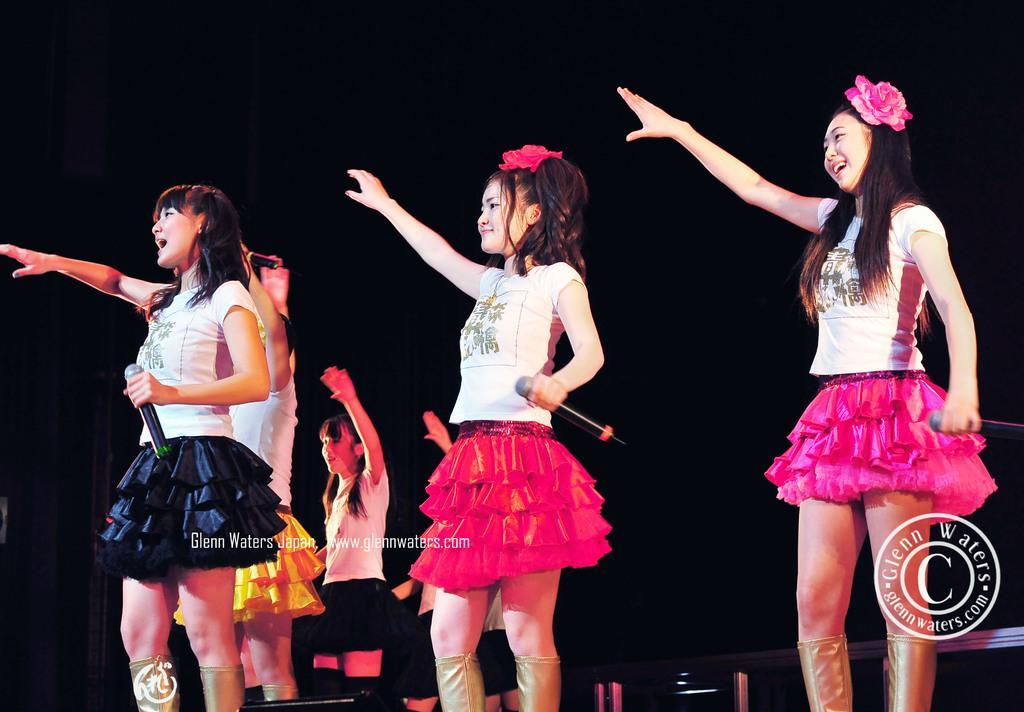Describe this image in one or two sentences. In this image, we can see three girls standing and they are holding microphones, there is a dark background. 